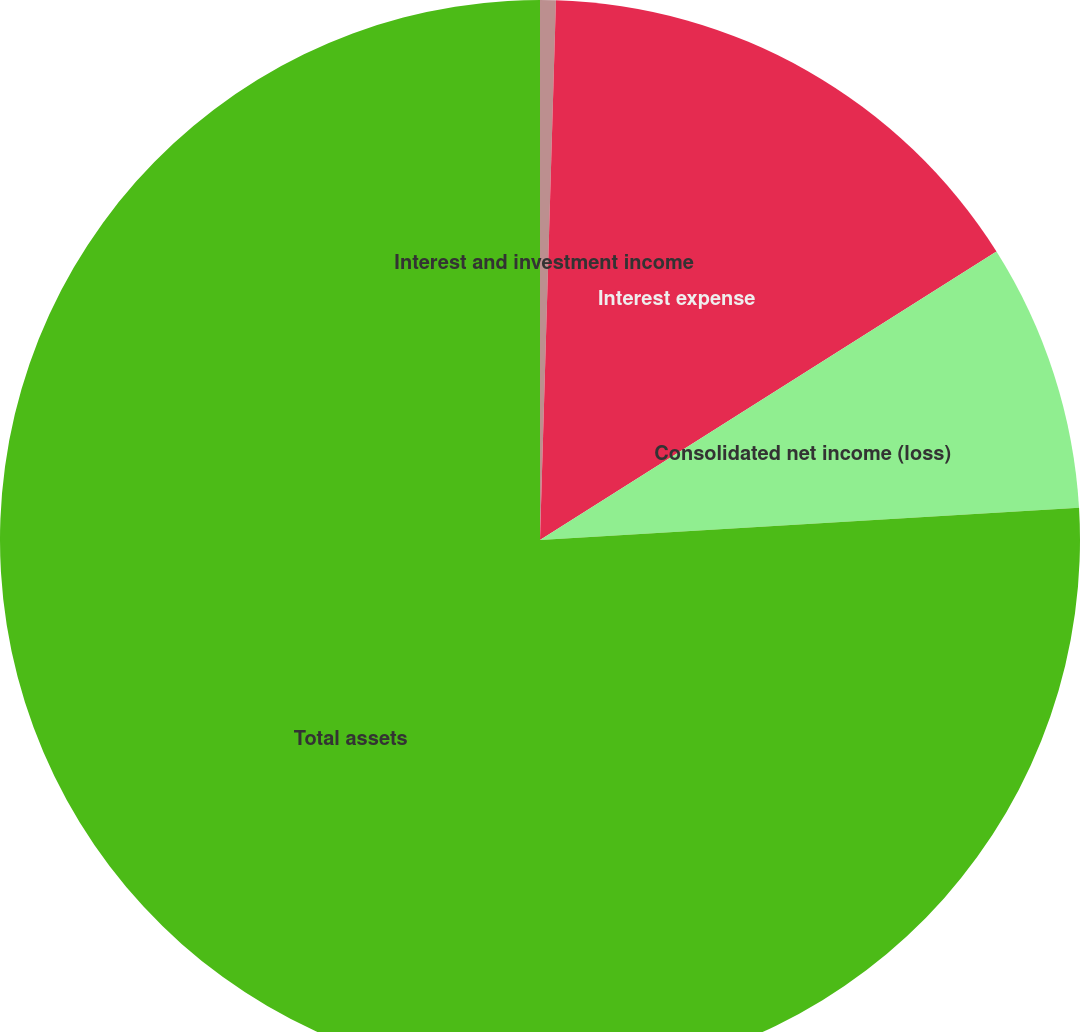<chart> <loc_0><loc_0><loc_500><loc_500><pie_chart><fcel>Interest and investment income<fcel>Interest expense<fcel>Consolidated net income (loss)<fcel>Total assets<nl><fcel>0.47%<fcel>15.56%<fcel>8.02%<fcel>75.95%<nl></chart> 